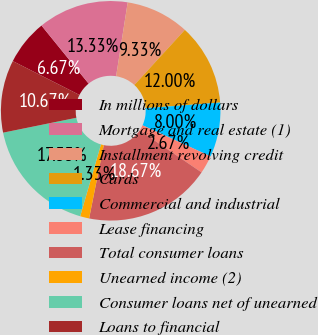Convert chart to OTSL. <chart><loc_0><loc_0><loc_500><loc_500><pie_chart><fcel>In millions of dollars<fcel>Mortgage and real estate (1)<fcel>Installment revolving credit<fcel>Cards<fcel>Commercial and industrial<fcel>Lease financing<fcel>Total consumer loans<fcel>Unearned income (2)<fcel>Consumer loans net of unearned<fcel>Loans to financial<nl><fcel>6.67%<fcel>13.33%<fcel>9.33%<fcel>12.0%<fcel>8.0%<fcel>2.67%<fcel>18.67%<fcel>1.33%<fcel>17.33%<fcel>10.67%<nl></chart> 